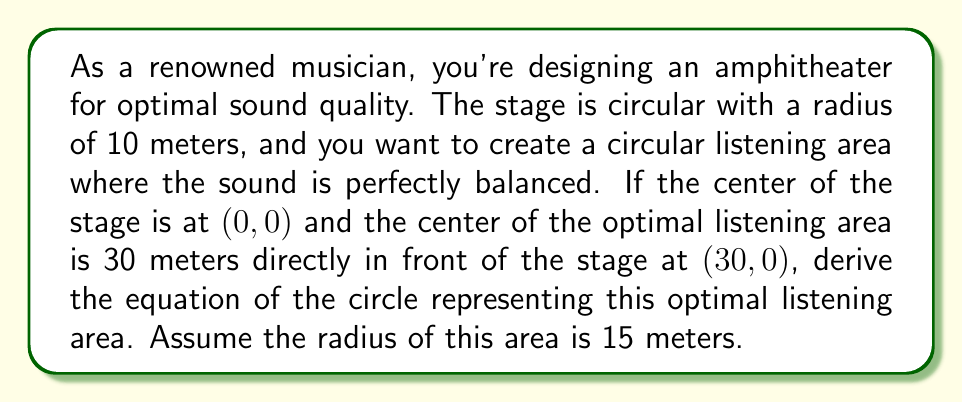What is the answer to this math problem? Let's approach this step-by-step:

1) The general equation of a circle is:
   $$(x - h)^2 + (y - k)^2 = r^2$$
   where $(h, k)$ is the center of the circle and $r$ is the radius.

2) We're given that:
   - The center of the optimal listening area is at (30, 0)
   - The radius of the optimal listening area is 15 meters

3) Therefore, we can identify:
   $h = 30$
   $k = 0$
   $r = 15$

4) Substituting these values into the general equation:
   $$(x - 30)^2 + (y - 0)^2 = 15^2$$

5) Simplify:
   $$(x - 30)^2 + y^2 = 225$$

6) This is the equation of the circle representing the optimal listening area.

[asy]
unitsize(4mm);
draw(circle((0,0),10), rgb(0.7,0.7,0.7));
draw(circle((30,0),15));
dot((0,0));
dot((30,0));
label("Stage", (0,-12));
label("Optimal Listening Area", (30,-17));
label("(0,0)", (-2,-2), SW);
label("(30,0)", (32,-2), SE);
draw((0,0)--(30,0), arrow=Arrow(TeXHead));
label("30m", (15,2), N);
[/asy]
Answer: $$(x - 30)^2 + y^2 = 225$$ 